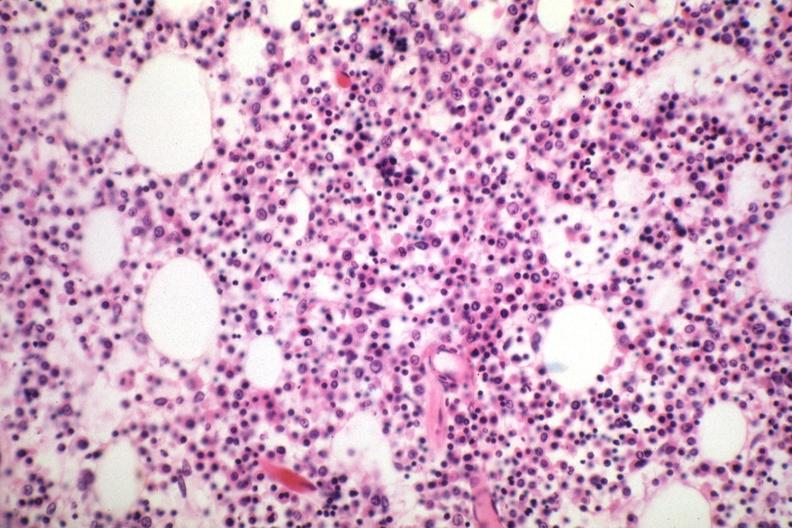s multiple myeloma present?
Answer the question using a single word or phrase. Yes 